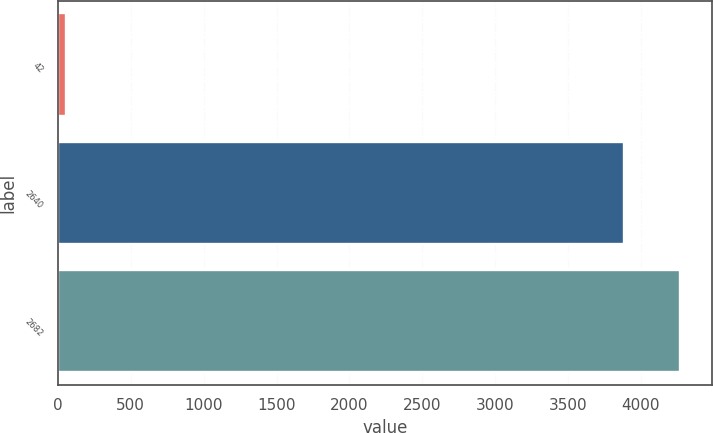<chart> <loc_0><loc_0><loc_500><loc_500><bar_chart><fcel>42<fcel>2640<fcel>2682<nl><fcel>58<fcel>3883<fcel>4271.3<nl></chart> 